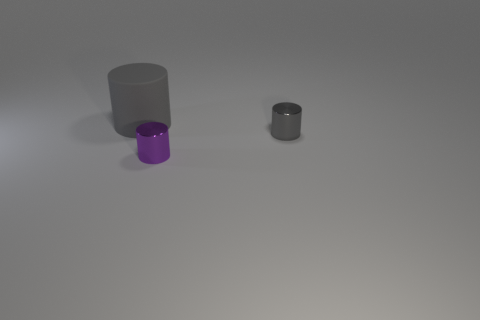Subtract all tiny cylinders. How many cylinders are left? 1 Subtract all purple cylinders. How many cylinders are left? 2 Add 3 gray matte things. How many objects exist? 6 Add 2 big rubber cylinders. How many big rubber cylinders are left? 3 Add 3 small purple objects. How many small purple objects exist? 4 Subtract 0 green blocks. How many objects are left? 3 Subtract 3 cylinders. How many cylinders are left? 0 Subtract all gray cylinders. Subtract all cyan blocks. How many cylinders are left? 1 Subtract all blue cubes. How many purple cylinders are left? 1 Subtract all small metal cylinders. Subtract all green spheres. How many objects are left? 1 